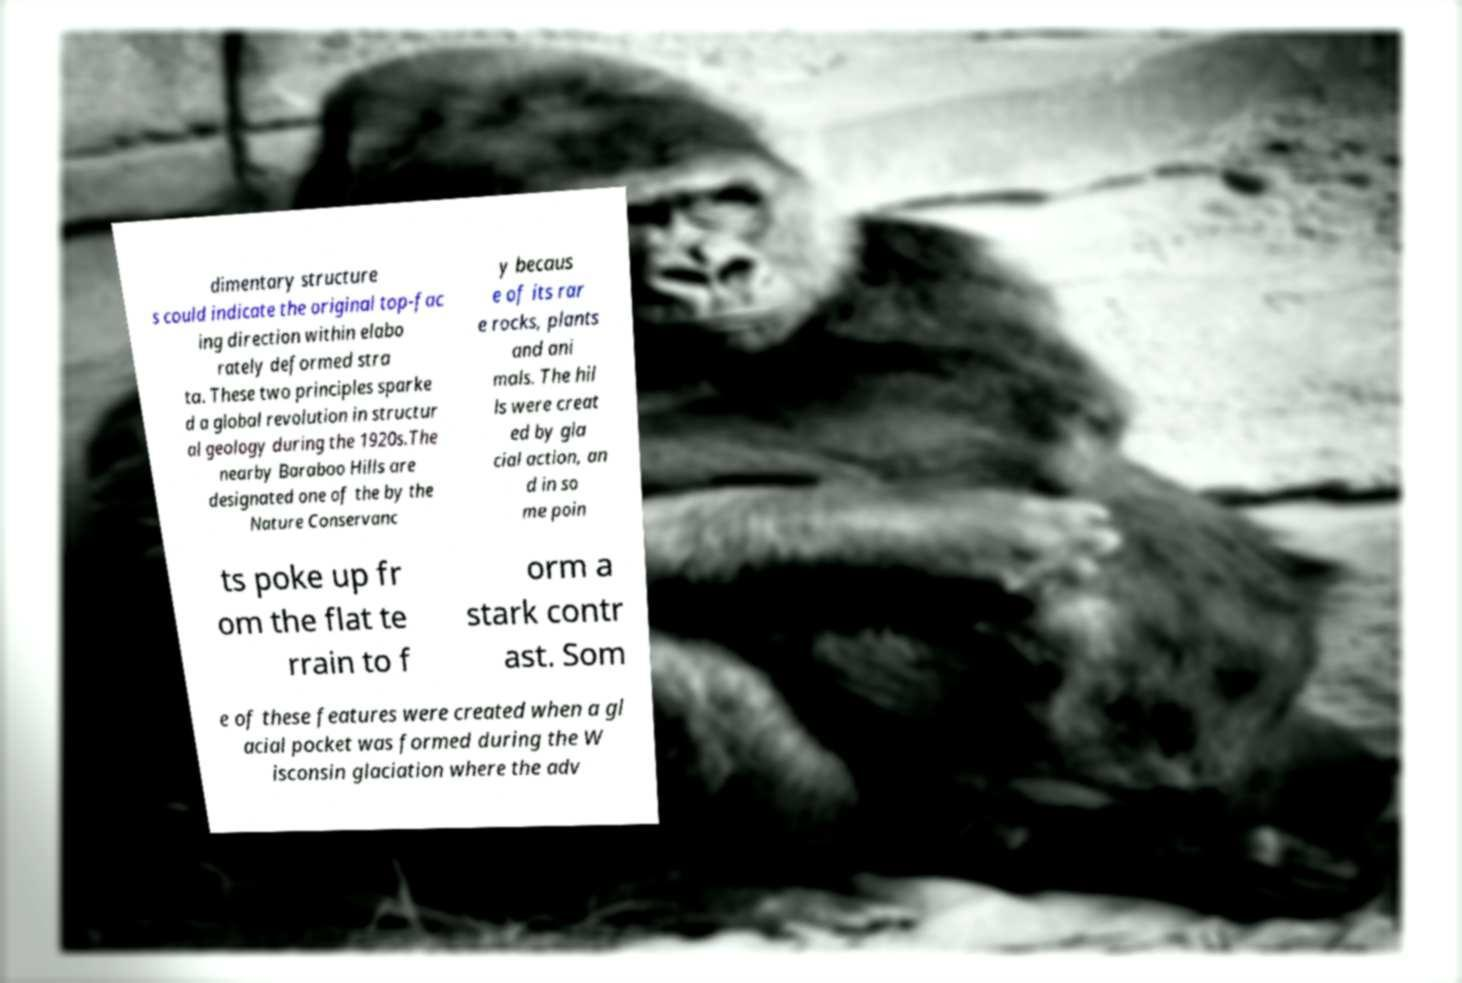Please read and relay the text visible in this image. What does it say? dimentary structure s could indicate the original top-fac ing direction within elabo rately deformed stra ta. These two principles sparke d a global revolution in structur al geology during the 1920s.The nearby Baraboo Hills are designated one of the by the Nature Conservanc y becaus e of its rar e rocks, plants and ani mals. The hil ls were creat ed by gla cial action, an d in so me poin ts poke up fr om the flat te rrain to f orm a stark contr ast. Som e of these features were created when a gl acial pocket was formed during the W isconsin glaciation where the adv 